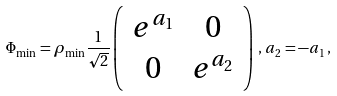Convert formula to latex. <formula><loc_0><loc_0><loc_500><loc_500>\Phi _ { \min } = \rho _ { \min } \frac { 1 } { \sqrt { 2 } } \left ( \begin{array} { c c } e ^ { a _ { 1 } } & 0 \\ 0 & e ^ { a _ { 2 } } \end{array} \right ) \, , \, a _ { 2 } = - a _ { 1 } \, ,</formula> 